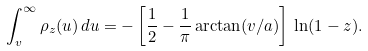Convert formula to latex. <formula><loc_0><loc_0><loc_500><loc_500>\int _ { v } ^ { \infty } \rho _ { z } ( u ) \, d u = - \left [ \frac { 1 } { 2 } - \frac { 1 } { \pi } \arctan ( v / a ) \right ] \, \ln ( 1 - z ) .</formula> 